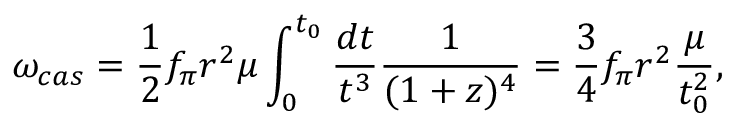Convert formula to latex. <formula><loc_0><loc_0><loc_500><loc_500>\omega _ { c a s } = \frac { 1 } { 2 } f _ { \pi } r ^ { 2 } \mu \int _ { 0 } ^ { t _ { 0 } } \frac { d t } { t ^ { 3 } } \frac { 1 } { ( 1 + z ) ^ { 4 } } = \frac { 3 } { 4 } f _ { \pi } r ^ { 2 } \frac { \mu } { t _ { 0 } ^ { 2 } } ,</formula> 